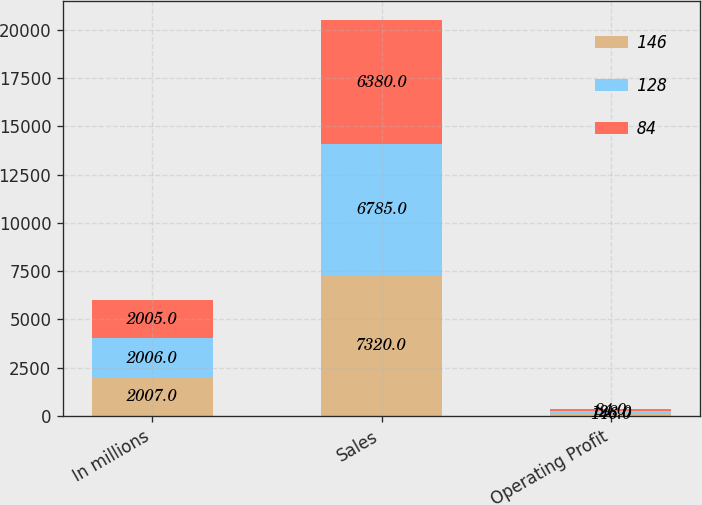Convert chart. <chart><loc_0><loc_0><loc_500><loc_500><stacked_bar_chart><ecel><fcel>In millions<fcel>Sales<fcel>Operating Profit<nl><fcel>146<fcel>2007<fcel>7320<fcel>146<nl><fcel>128<fcel>2006<fcel>6785<fcel>128<nl><fcel>84<fcel>2005<fcel>6380<fcel>84<nl></chart> 